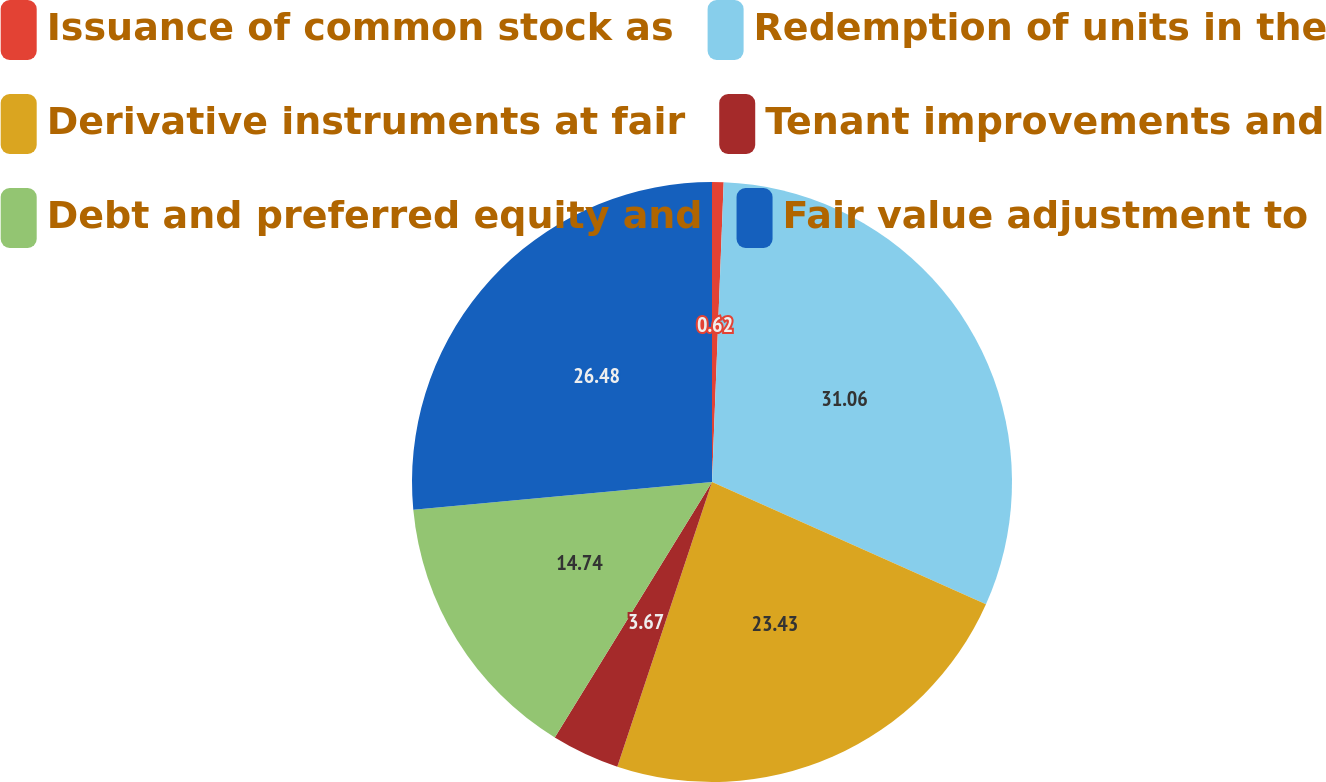Convert chart. <chart><loc_0><loc_0><loc_500><loc_500><pie_chart><fcel>Issuance of common stock as<fcel>Redemption of units in the<fcel>Derivative instruments at fair<fcel>Tenant improvements and<fcel>Debt and preferred equity and<fcel>Fair value adjustment to<nl><fcel>0.62%<fcel>31.06%<fcel>23.43%<fcel>3.67%<fcel>14.74%<fcel>26.48%<nl></chart> 